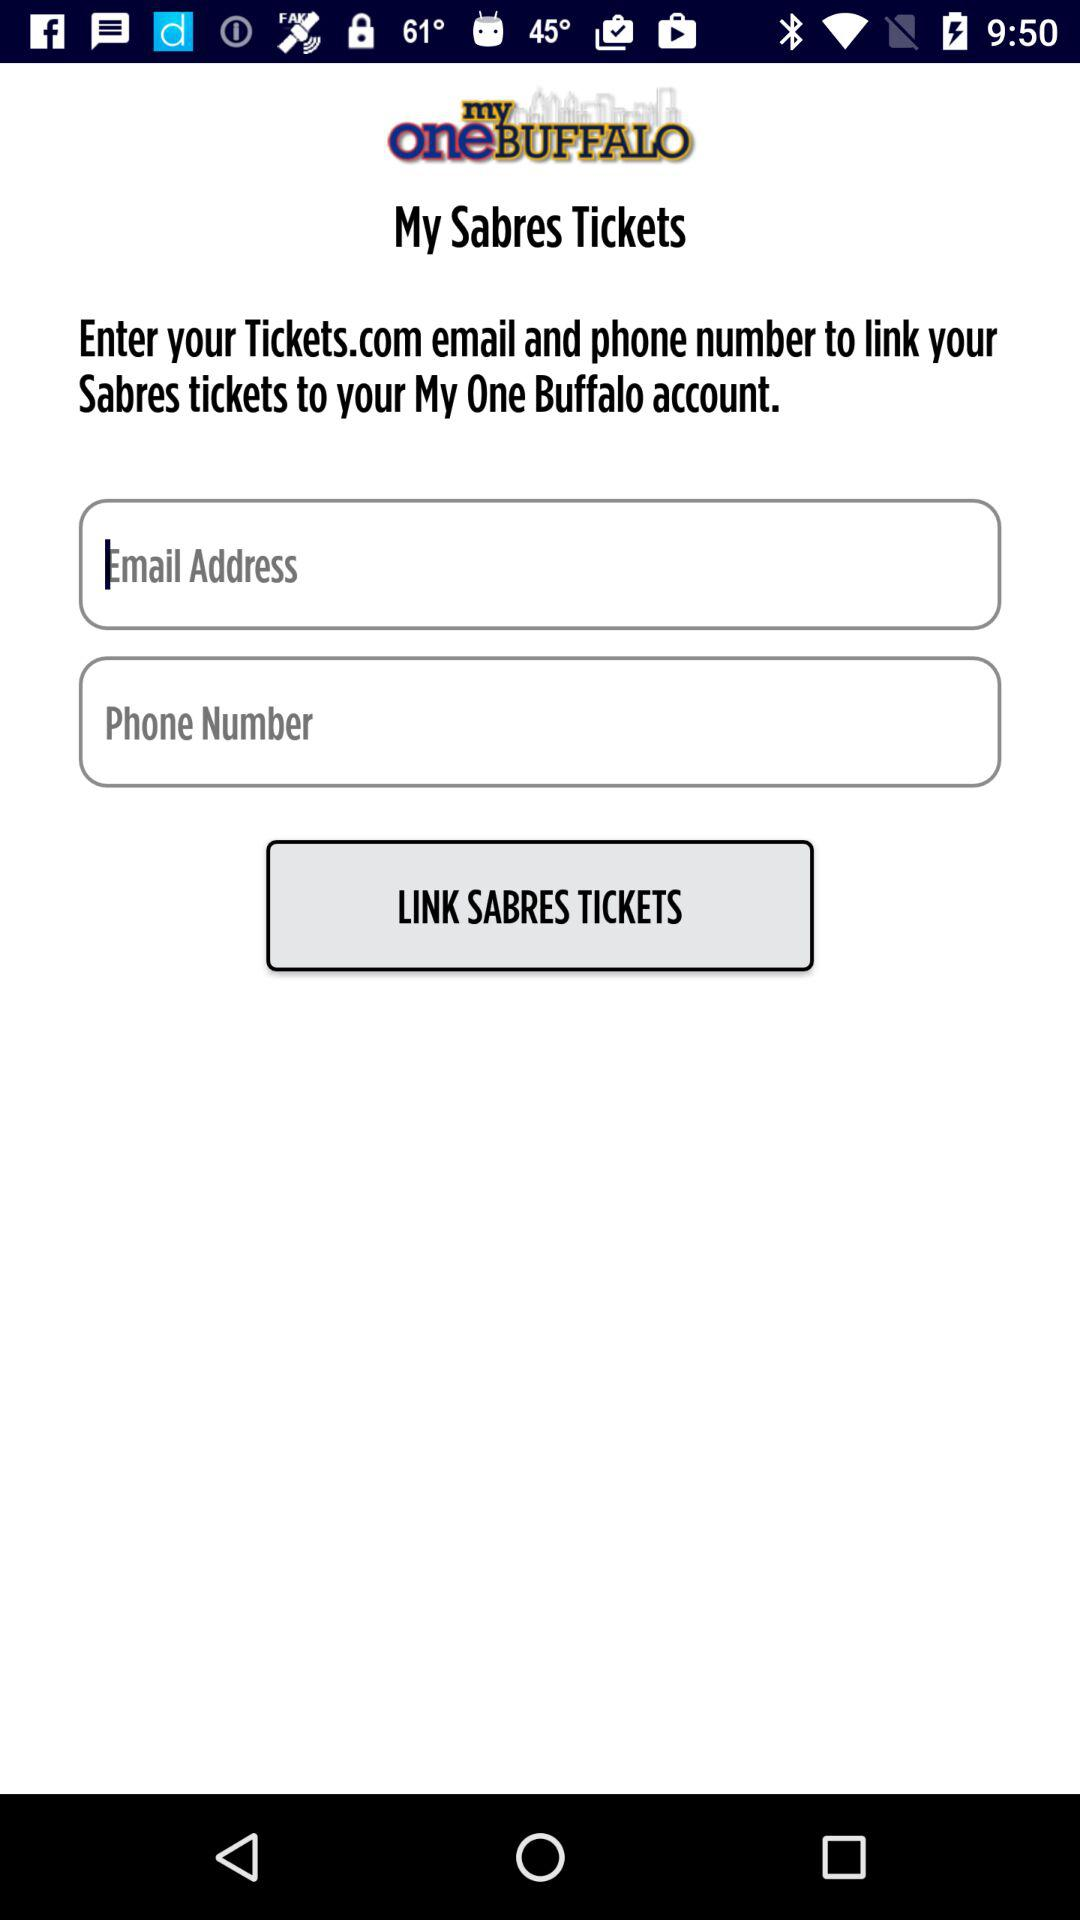What is the application name? The application name is "my one BUFFALO". 